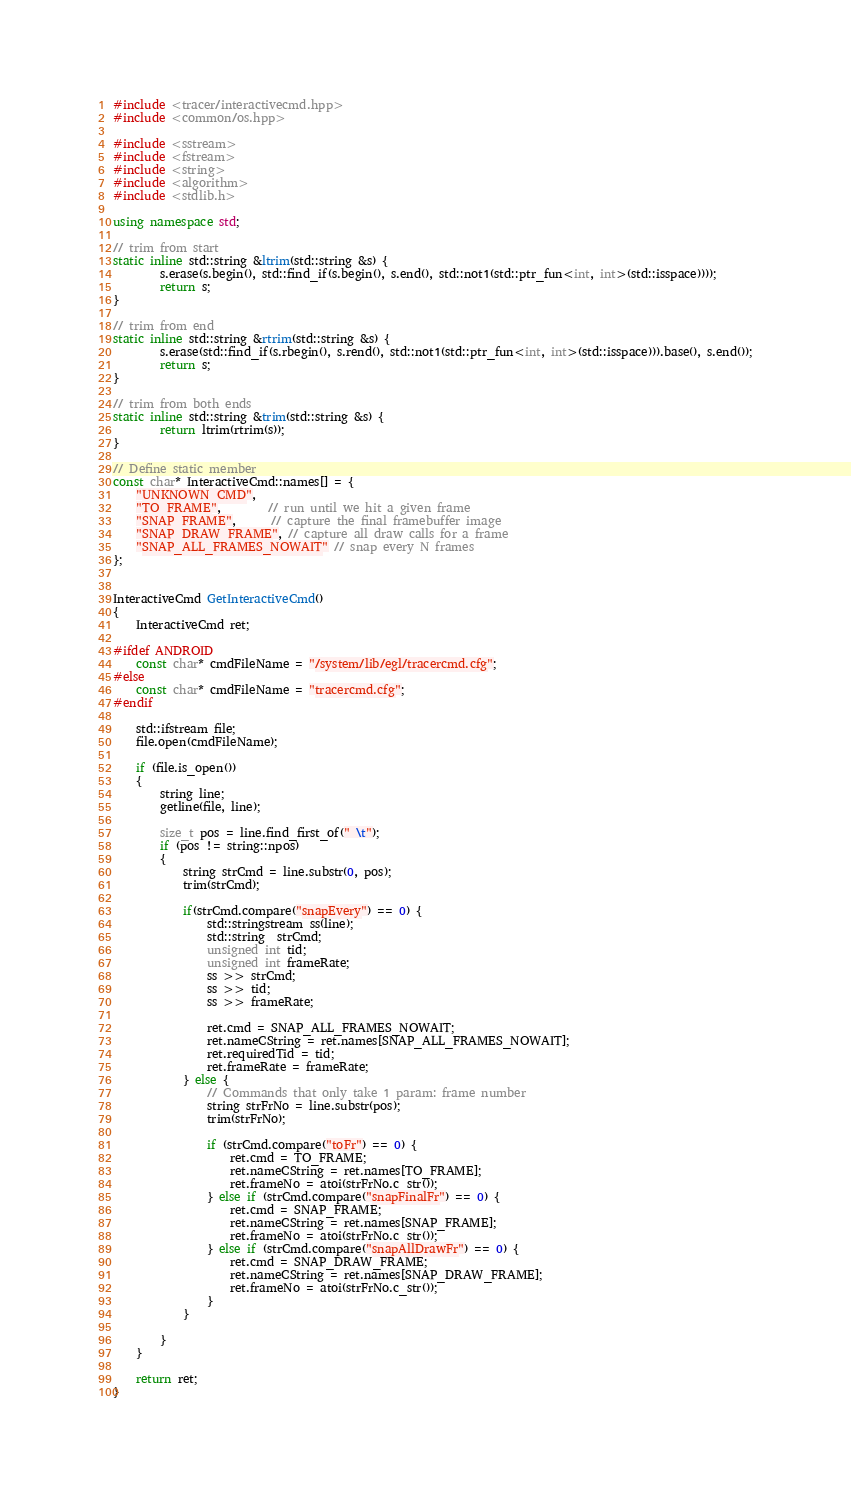Convert code to text. <code><loc_0><loc_0><loc_500><loc_500><_C++_>#include <tracer/interactivecmd.hpp>
#include <common/os.hpp>

#include <sstream>
#include <fstream>
#include <string>
#include <algorithm>
#include <stdlib.h>

using namespace std;

// trim from start
static inline std::string &ltrim(std::string &s) {
        s.erase(s.begin(), std::find_if(s.begin(), s.end(), std::not1(std::ptr_fun<int, int>(std::isspace))));
        return s;
}

// trim from end
static inline std::string &rtrim(std::string &s) {
        s.erase(std::find_if(s.rbegin(), s.rend(), std::not1(std::ptr_fun<int, int>(std::isspace))).base(), s.end());
        return s;
}

// trim from both ends
static inline std::string &trim(std::string &s) {
        return ltrim(rtrim(s));
}

// Define static member
const char* InteractiveCmd::names[] = {
    "UNKNOWN_CMD",
    "TO_FRAME",        // run until we hit a given frame
    "SNAP_FRAME",      // capture the final framebuffer image
    "SNAP_DRAW_FRAME", // capture all draw calls for a frame
    "SNAP_ALL_FRAMES_NOWAIT" // snap every N frames
};


InteractiveCmd GetInteractiveCmd()
{
    InteractiveCmd ret;

#ifdef ANDROID
    const char* cmdFileName = "/system/lib/egl/tracercmd.cfg";
#else
    const char* cmdFileName = "tracercmd.cfg";
#endif

    std::ifstream file;
    file.open(cmdFileName);

    if (file.is_open())
    {
        string line;
        getline(file, line);

        size_t pos = line.find_first_of(" \t");
        if (pos != string::npos)
        {
            string strCmd = line.substr(0, pos);
            trim(strCmd);

            if(strCmd.compare("snapEvery") == 0) {
                std::stringstream ss(line);
                std::string  strCmd;
                unsigned int tid;
                unsigned int frameRate;
                ss >> strCmd;
                ss >> tid;
                ss >> frameRate;

                ret.cmd = SNAP_ALL_FRAMES_NOWAIT;
                ret.nameCString = ret.names[SNAP_ALL_FRAMES_NOWAIT];
                ret.requiredTid = tid;
                ret.frameRate = frameRate;
            } else {
                // Commands that only take 1 param: frame number
                string strFrNo = line.substr(pos);
                trim(strFrNo);

                if (strCmd.compare("toFr") == 0) {
                    ret.cmd = TO_FRAME;
                    ret.nameCString = ret.names[TO_FRAME];
                    ret.frameNo = atoi(strFrNo.c_str());
                } else if (strCmd.compare("snapFinalFr") == 0) {
                    ret.cmd = SNAP_FRAME;
                    ret.nameCString = ret.names[SNAP_FRAME];
                    ret.frameNo = atoi(strFrNo.c_str());
                } else if (strCmd.compare("snapAllDrawFr") == 0) {
                    ret.cmd = SNAP_DRAW_FRAME;
                    ret.nameCString = ret.names[SNAP_DRAW_FRAME];
                    ret.frameNo = atoi(strFrNo.c_str());
                }
            }

        }
    }

    return ret;
}

</code> 